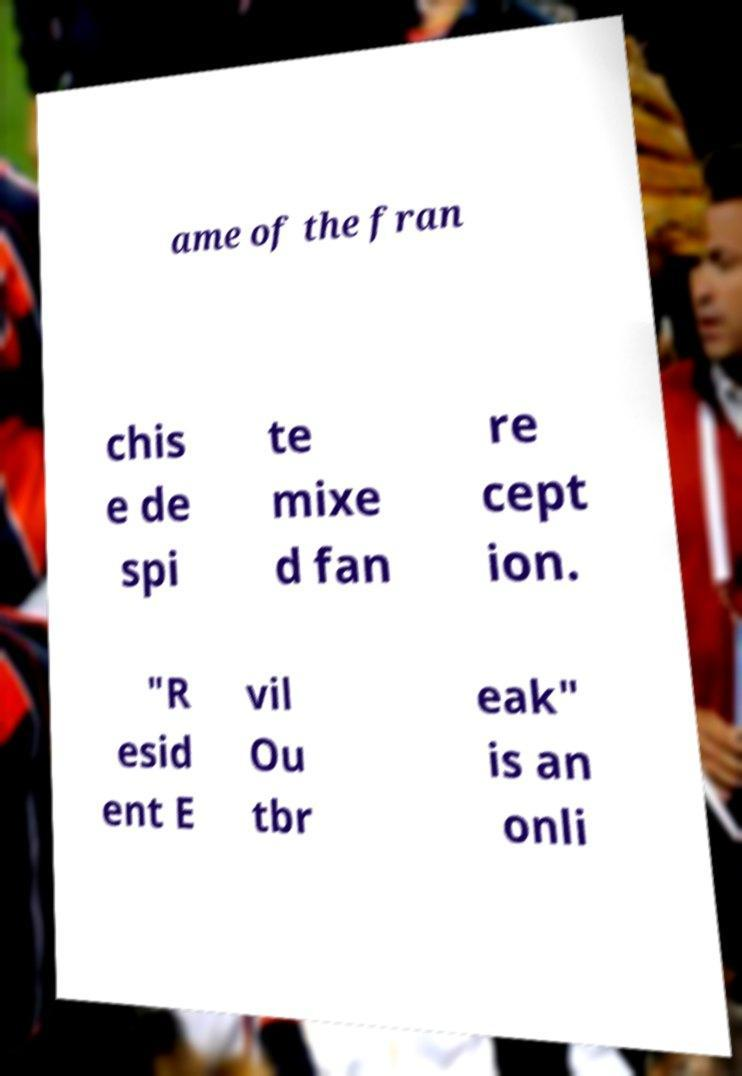There's text embedded in this image that I need extracted. Can you transcribe it verbatim? ame of the fran chis e de spi te mixe d fan re cept ion. "R esid ent E vil Ou tbr eak" is an onli 